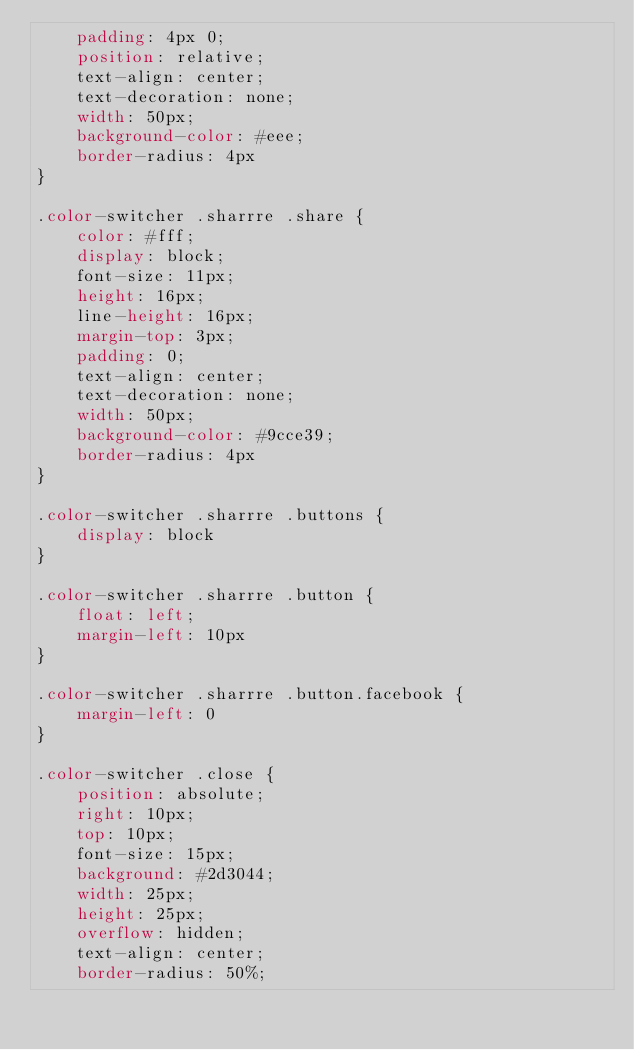<code> <loc_0><loc_0><loc_500><loc_500><_CSS_>    padding: 4px 0;
    position: relative;
    text-align: center;
    text-decoration: none;
    width: 50px;
    background-color: #eee;
    border-radius: 4px
}

.color-switcher .sharrre .share {
    color: #fff;
    display: block;
    font-size: 11px;
    height: 16px;
    line-height: 16px;
    margin-top: 3px;
    padding: 0;
    text-align: center;
    text-decoration: none;
    width: 50px;
    background-color: #9cce39;
    border-radius: 4px
}

.color-switcher .sharrre .buttons {
    display: block
}

.color-switcher .sharrre .button {
    float: left;
    margin-left: 10px
}

.color-switcher .sharrre .button.facebook {
    margin-left: 0
}

.color-switcher .close {
    position: absolute;
    right: 10px;
    top: 10px;
    font-size: 15px;
    background: #2d3044;
    width: 25px;
    height: 25px;
    overflow: hidden;
    text-align: center;
    border-radius: 50%;</code> 